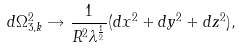Convert formula to latex. <formula><loc_0><loc_0><loc_500><loc_500>d \Omega _ { 3 , k } ^ { 2 } \rightarrow \frac { 1 } { R ^ { 2 } \lambda ^ { \frac { 1 } { 2 } } } ( d x ^ { 2 } + d y ^ { 2 } + d z ^ { 2 } ) ,</formula> 